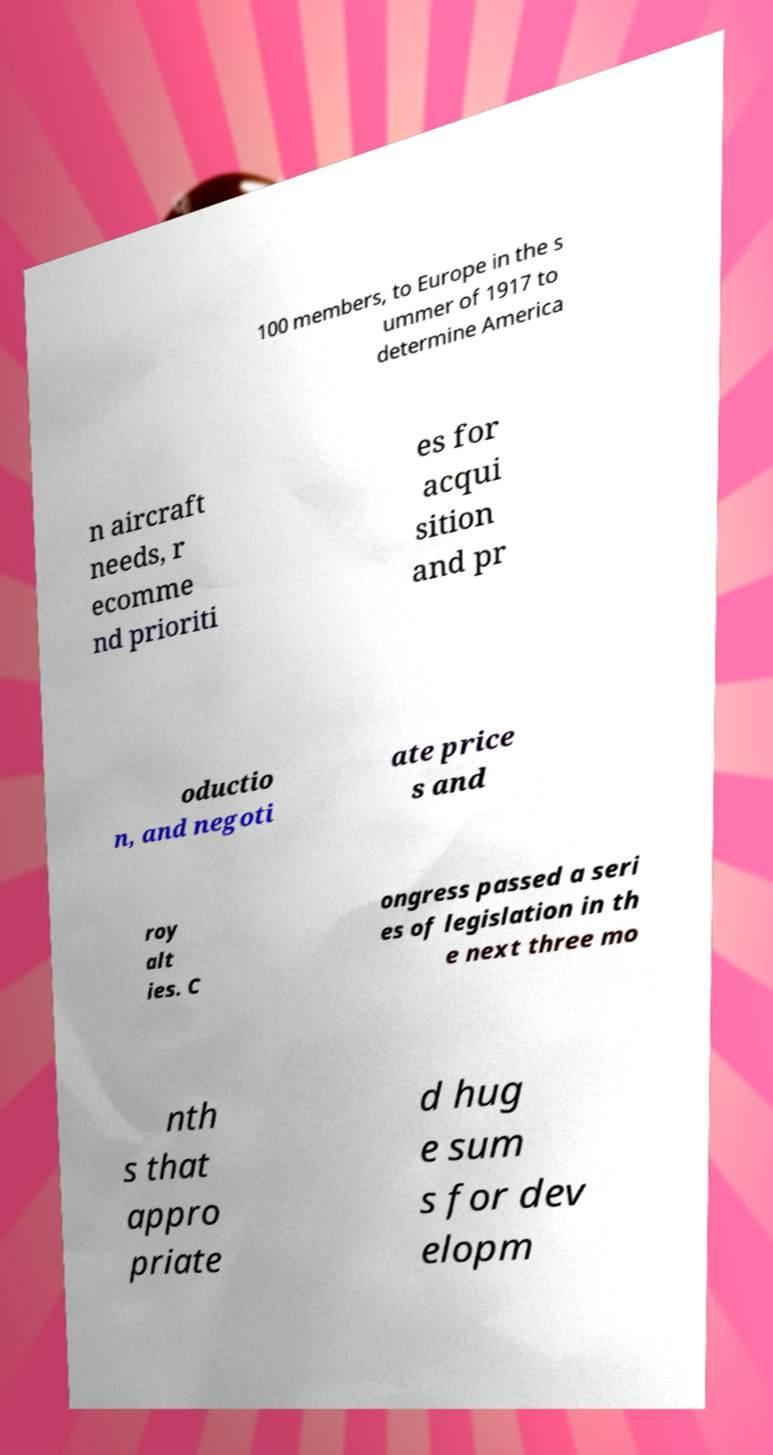Can you read and provide the text displayed in the image?This photo seems to have some interesting text. Can you extract and type it out for me? 100 members, to Europe in the s ummer of 1917 to determine America n aircraft needs, r ecomme nd prioriti es for acqui sition and pr oductio n, and negoti ate price s and roy alt ies. C ongress passed a seri es of legislation in th e next three mo nth s that appro priate d hug e sum s for dev elopm 